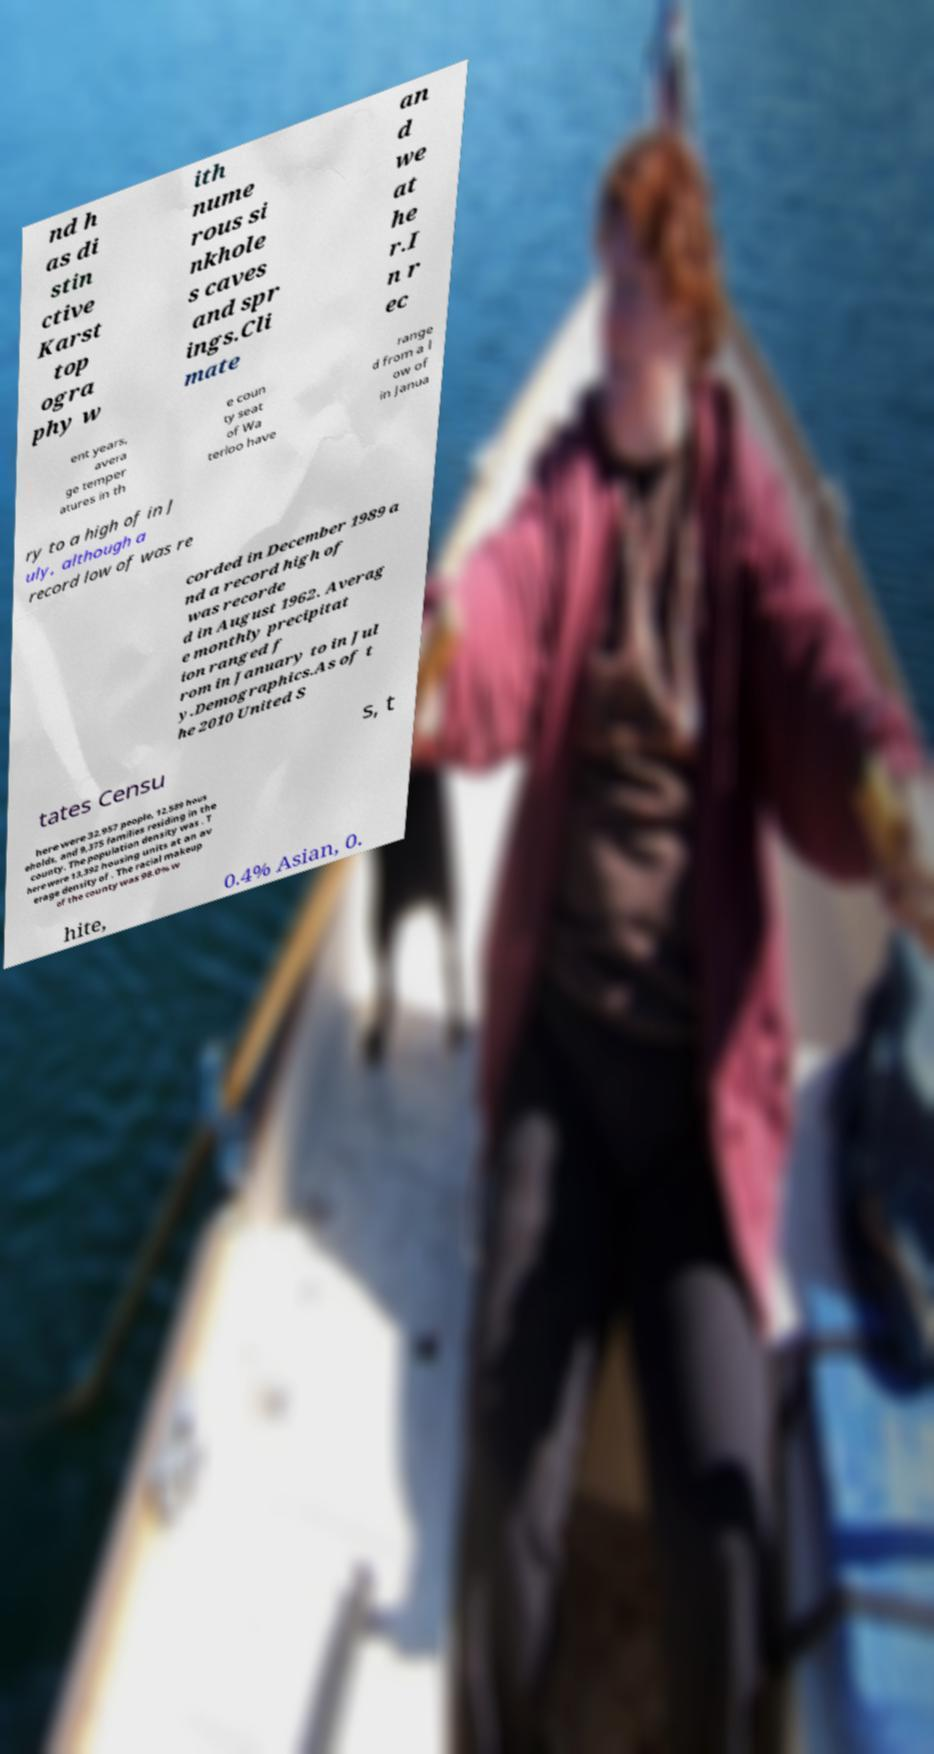I need the written content from this picture converted into text. Can you do that? nd h as di stin ctive Karst top ogra phy w ith nume rous si nkhole s caves and spr ings.Cli mate an d we at he r.I n r ec ent years, avera ge temper atures in th e coun ty seat of Wa terloo have range d from a l ow of in Janua ry to a high of in J uly, although a record low of was re corded in December 1989 a nd a record high of was recorde d in August 1962. Averag e monthly precipitat ion ranged f rom in January to in Jul y.Demographics.As of t he 2010 United S tates Censu s, t here were 32,957 people, 12,589 hous eholds, and 9,375 families residing in the county. The population density was . T here were 13,392 housing units at an av erage density of . The racial makeup of the county was 98.0% w hite, 0.4% Asian, 0. 